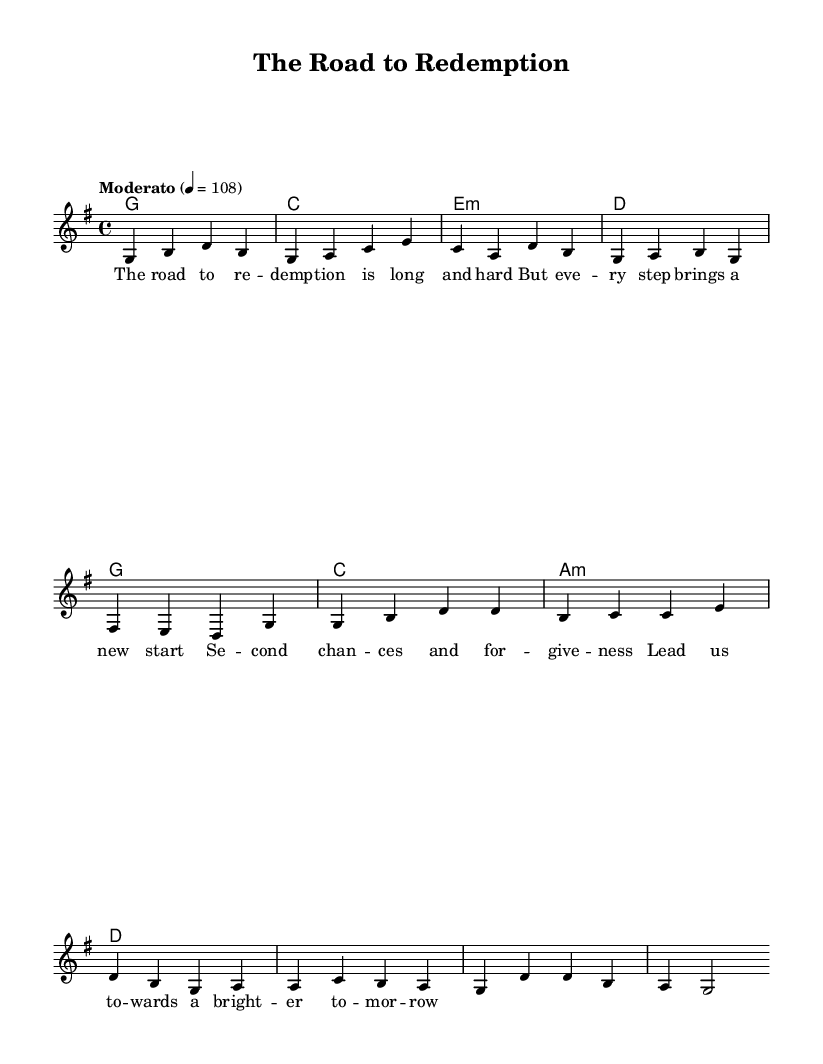What is the key signature of this music? The key signature shows one sharp (F#), which indicates that this piece is in G major.
Answer: G major What is the time signature of this music? The time signature is indicated at the beginning of the score as 4/4, meaning there are four beats in each measure, and a quarter note receives one beat.
Answer: 4/4 What is the tempo marking of this piece? The tempo marking is indicated as "Moderato" with a metronome marking of 108 beats per minute, suggesting a moderate speed for the piece.
Answer: Moderato How many measures are there in the verse section? The verse section consists of four measures as indicated in the melody part of the score where the first eight notes are grouped in four measures.
Answer: 4 What chord is played on the third measure of the verse? The chord written for the third measure is E minor, which is represented as "e:m" in the harmonies section of the score.
Answer: E minor What is the lyric theme of this song? The lyrics suggest themes of redemption, second chances, and the journey towards a brighter future, reflecting the overall focus of the song on personal growth and forgiveness.
Answer: Redemption What type of music style does this piece belong to? The piece combines elements of country and rock music, characterized by storytelling lyrics, guitar-driven melodies, and a strong backbeat, embodying the country rock style.
Answer: Country rock 